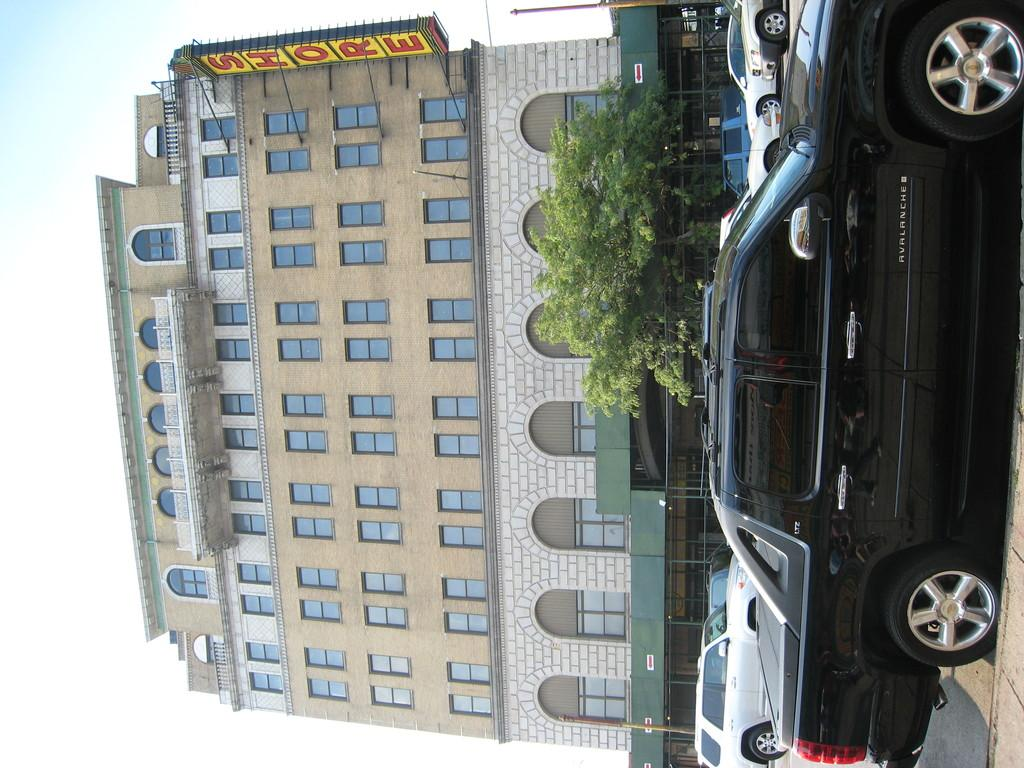What type of structure is present in the image? There is a building in the image. What features can be observed on the building? The building has windows and glass doors. What other object is present in the image? There is a tree in the image. What can be seen on the road in the image? Cars are visible on the road. Is there any signage or identification on the building? Yes, there is a name board attached to the building. What type of lead is used to draw on the chalkboard in the image? There is no chalkboard or lead present in the image. How is the glue used to stick the papers on the wall in the image? There is no glue or papers on the wall in the image. 